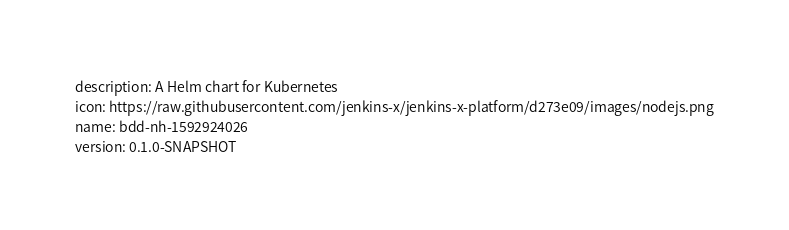Convert code to text. <code><loc_0><loc_0><loc_500><loc_500><_YAML_>description: A Helm chart for Kubernetes
icon: https://raw.githubusercontent.com/jenkins-x/jenkins-x-platform/d273e09/images/nodejs.png
name: bdd-nh-1592924026
version: 0.1.0-SNAPSHOT
</code> 